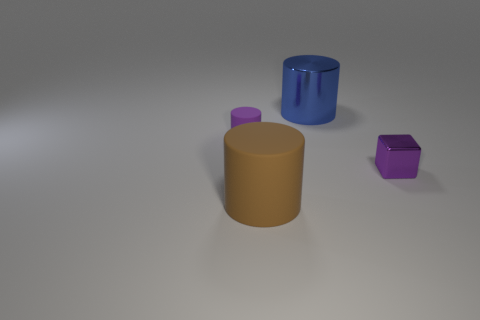Subtract all blue shiny cylinders. How many cylinders are left? 2 Add 4 blue metallic things. How many objects exist? 8 Subtract all cubes. How many objects are left? 3 Subtract all brown matte objects. Subtract all cyan metal objects. How many objects are left? 3 Add 4 big metallic objects. How many big metallic objects are left? 5 Add 3 small purple cylinders. How many small purple cylinders exist? 4 Subtract 1 purple cylinders. How many objects are left? 3 